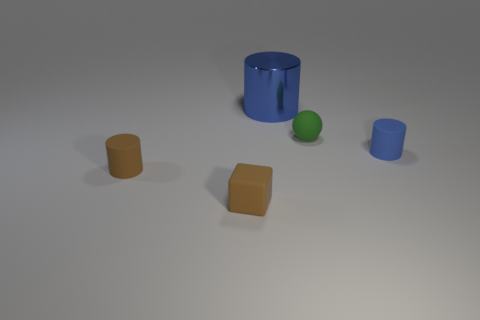Subtract all purple cylinders. Subtract all purple spheres. How many cylinders are left? 3 Add 1 brown cylinders. How many objects exist? 6 Subtract all cylinders. How many objects are left? 2 Add 4 red metal cylinders. How many red metal cylinders exist? 4 Subtract 0 cyan spheres. How many objects are left? 5 Subtract all tiny matte objects. Subtract all rubber spheres. How many objects are left? 0 Add 5 small brown blocks. How many small brown blocks are left? 6 